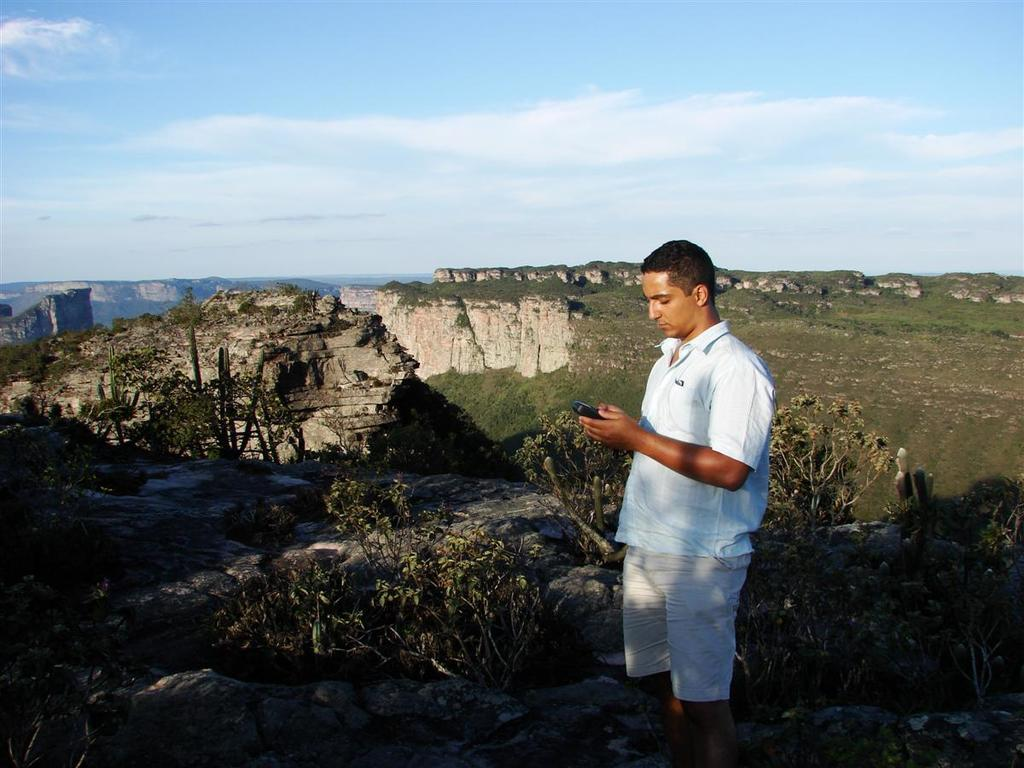Who is the main subject in the image? There is a man in the center of the image. What is the man holding in the image? The man is holding a phone. What can be seen in the background of the image? Hills, the sky, trees, and clouds are visible in the background of the image. How many rings are visible on the man's fingers in the image? There is no information about rings on the man's fingers in the image, so we cannot determine the number of rings. 